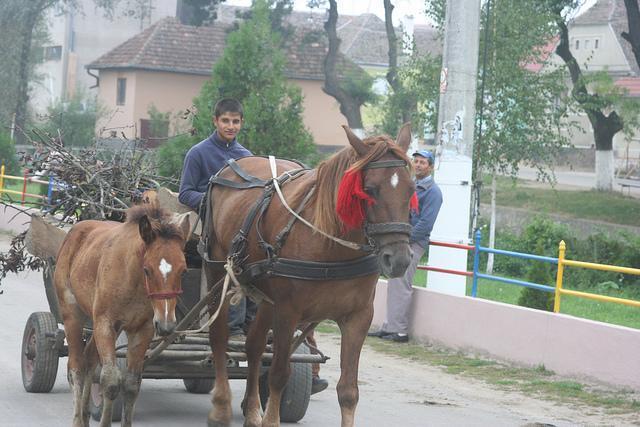How many people are there?
Give a very brief answer. 2. How many horses are there?
Give a very brief answer. 2. How many pizza paddles are on top of the oven?
Give a very brief answer. 0. 